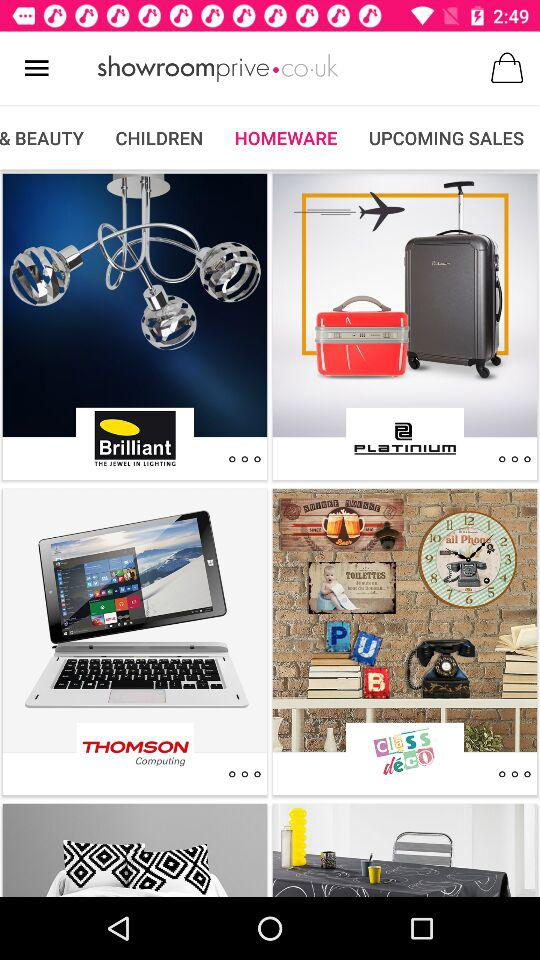Which items will be on sale soon?
When the provided information is insufficient, respond with <no answer>. <no answer> 